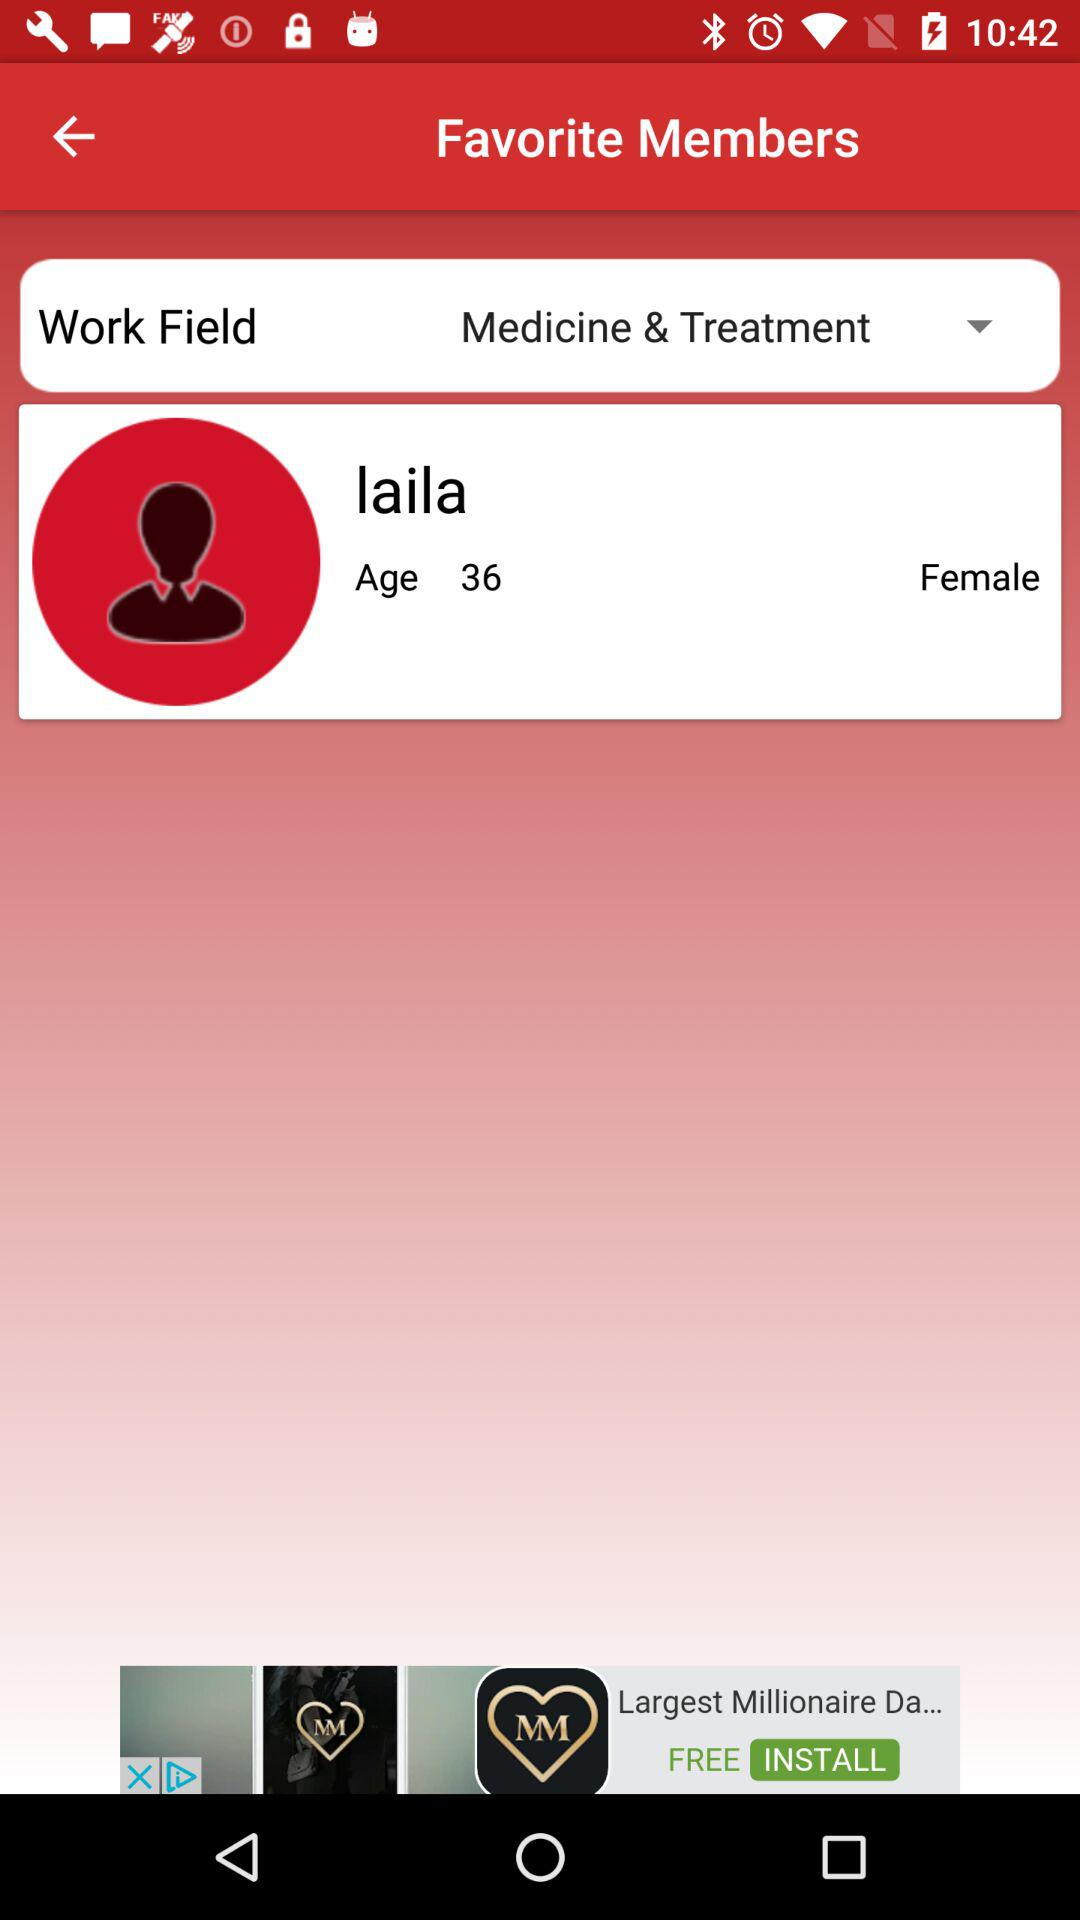What is the field of work? The field of work is "Medical & Treatment". 